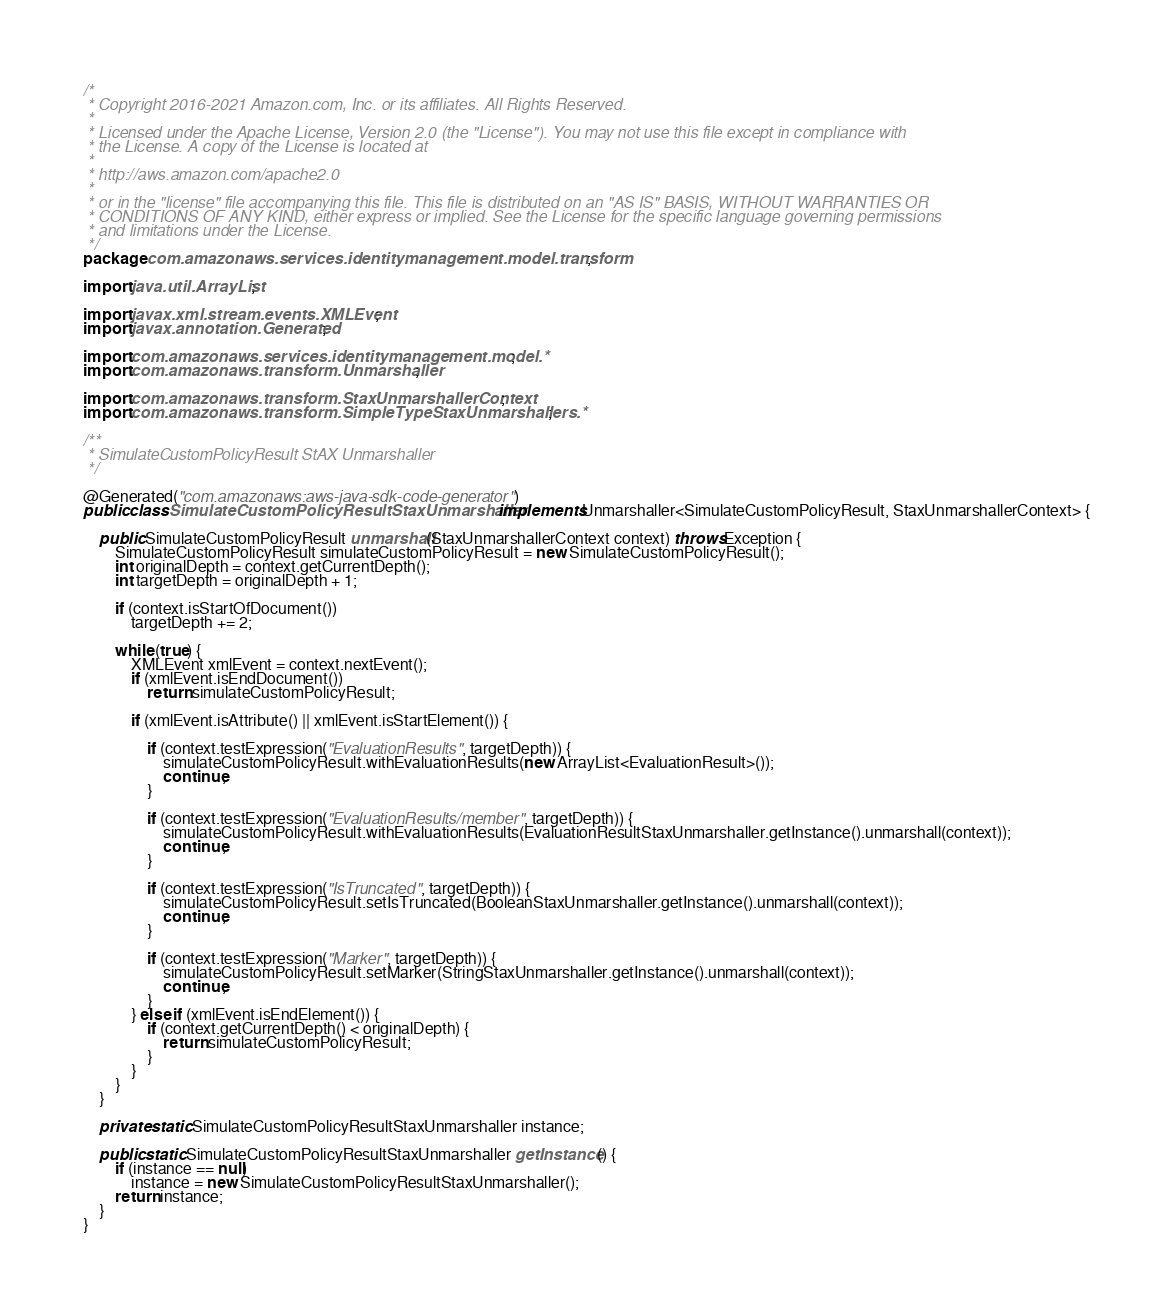Convert code to text. <code><loc_0><loc_0><loc_500><loc_500><_Java_>/*
 * Copyright 2016-2021 Amazon.com, Inc. or its affiliates. All Rights Reserved.
 * 
 * Licensed under the Apache License, Version 2.0 (the "License"). You may not use this file except in compliance with
 * the License. A copy of the License is located at
 * 
 * http://aws.amazon.com/apache2.0
 * 
 * or in the "license" file accompanying this file. This file is distributed on an "AS IS" BASIS, WITHOUT WARRANTIES OR
 * CONDITIONS OF ANY KIND, either express or implied. See the License for the specific language governing permissions
 * and limitations under the License.
 */
package com.amazonaws.services.identitymanagement.model.transform;

import java.util.ArrayList;

import javax.xml.stream.events.XMLEvent;
import javax.annotation.Generated;

import com.amazonaws.services.identitymanagement.model.*;
import com.amazonaws.transform.Unmarshaller;

import com.amazonaws.transform.StaxUnmarshallerContext;
import com.amazonaws.transform.SimpleTypeStaxUnmarshallers.*;

/**
 * SimulateCustomPolicyResult StAX Unmarshaller
 */

@Generated("com.amazonaws:aws-java-sdk-code-generator")
public class SimulateCustomPolicyResultStaxUnmarshaller implements Unmarshaller<SimulateCustomPolicyResult, StaxUnmarshallerContext> {

    public SimulateCustomPolicyResult unmarshall(StaxUnmarshallerContext context) throws Exception {
        SimulateCustomPolicyResult simulateCustomPolicyResult = new SimulateCustomPolicyResult();
        int originalDepth = context.getCurrentDepth();
        int targetDepth = originalDepth + 1;

        if (context.isStartOfDocument())
            targetDepth += 2;

        while (true) {
            XMLEvent xmlEvent = context.nextEvent();
            if (xmlEvent.isEndDocument())
                return simulateCustomPolicyResult;

            if (xmlEvent.isAttribute() || xmlEvent.isStartElement()) {

                if (context.testExpression("EvaluationResults", targetDepth)) {
                    simulateCustomPolicyResult.withEvaluationResults(new ArrayList<EvaluationResult>());
                    continue;
                }

                if (context.testExpression("EvaluationResults/member", targetDepth)) {
                    simulateCustomPolicyResult.withEvaluationResults(EvaluationResultStaxUnmarshaller.getInstance().unmarshall(context));
                    continue;
                }

                if (context.testExpression("IsTruncated", targetDepth)) {
                    simulateCustomPolicyResult.setIsTruncated(BooleanStaxUnmarshaller.getInstance().unmarshall(context));
                    continue;
                }

                if (context.testExpression("Marker", targetDepth)) {
                    simulateCustomPolicyResult.setMarker(StringStaxUnmarshaller.getInstance().unmarshall(context));
                    continue;
                }
            } else if (xmlEvent.isEndElement()) {
                if (context.getCurrentDepth() < originalDepth) {
                    return simulateCustomPolicyResult;
                }
            }
        }
    }

    private static SimulateCustomPolicyResultStaxUnmarshaller instance;

    public static SimulateCustomPolicyResultStaxUnmarshaller getInstance() {
        if (instance == null)
            instance = new SimulateCustomPolicyResultStaxUnmarshaller();
        return instance;
    }
}
</code> 